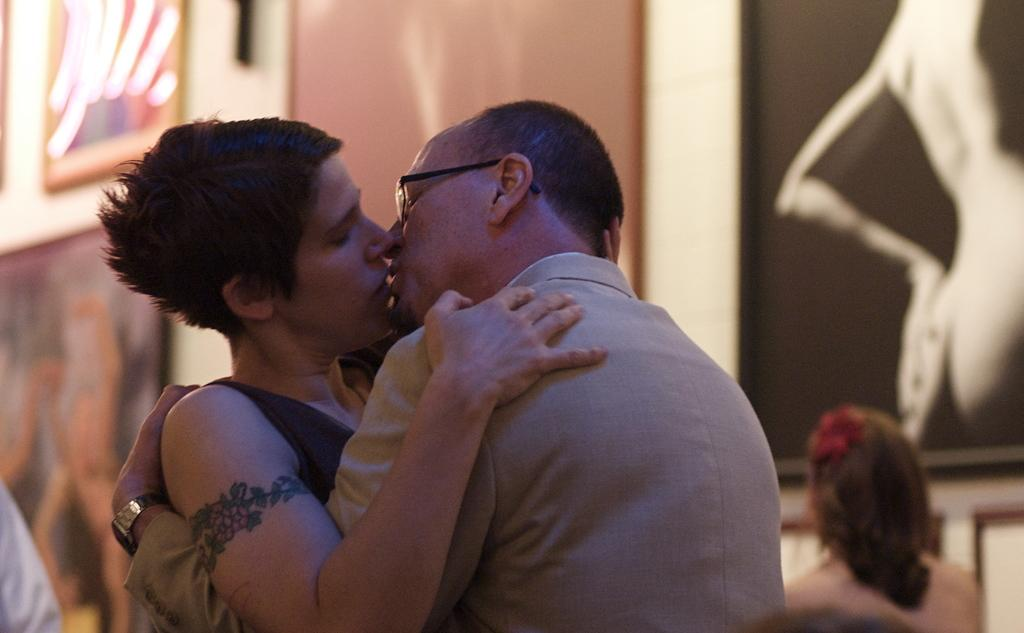What are the two people in the image doing? There is a man and a woman kissing in the image. Can you describe the woman in the background of the image? There is a woman sitting on a chair in the background of the image. What can be seen on the wall in the background of the image? There are photo frames on the wall in the background of the image. How would you describe the overall quality of the image? The image is blurred. What type of whistle is the man using to communicate with the doctor in the image? There is no whistle or doctor present in the image; it features a man and a woman kissing, a woman sitting on a chair, and photo frames on the wall. 